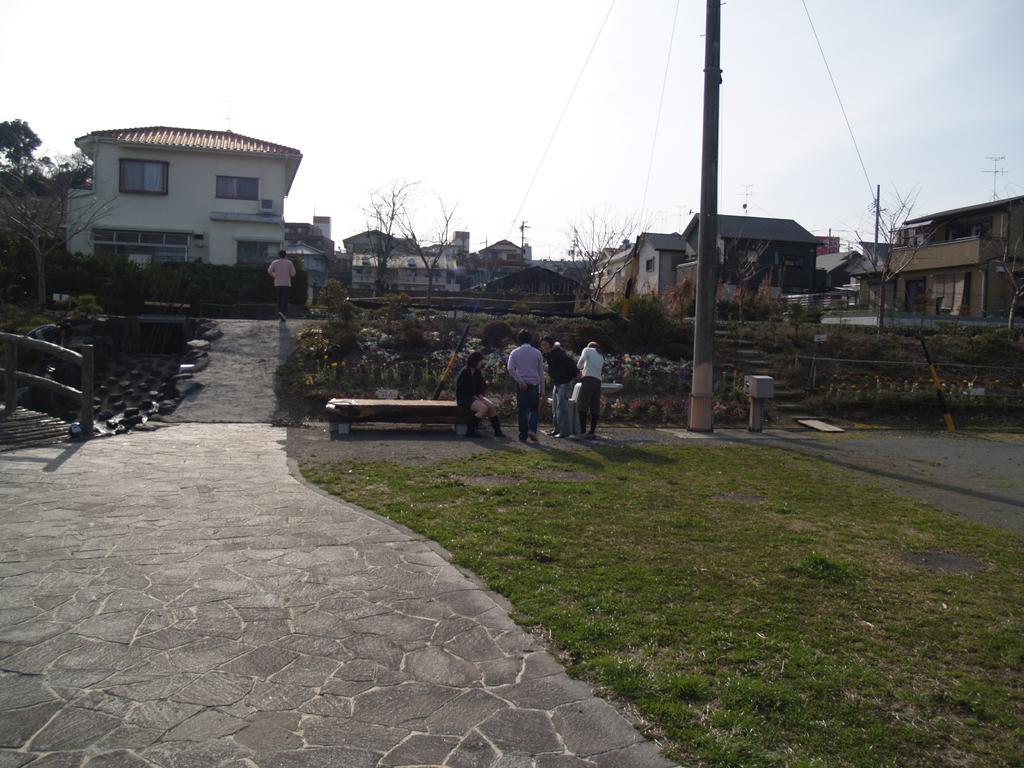Please provide a concise description of this image. In this image, I can see a person sitting on a bench and three persons standing. At the bottom of the image, I can see the grass and a pathway. There are houses, trees, plants, pole and a person walking. In the background, there is the sky. On the left corner of the image, It looks like a wooden bridge. 